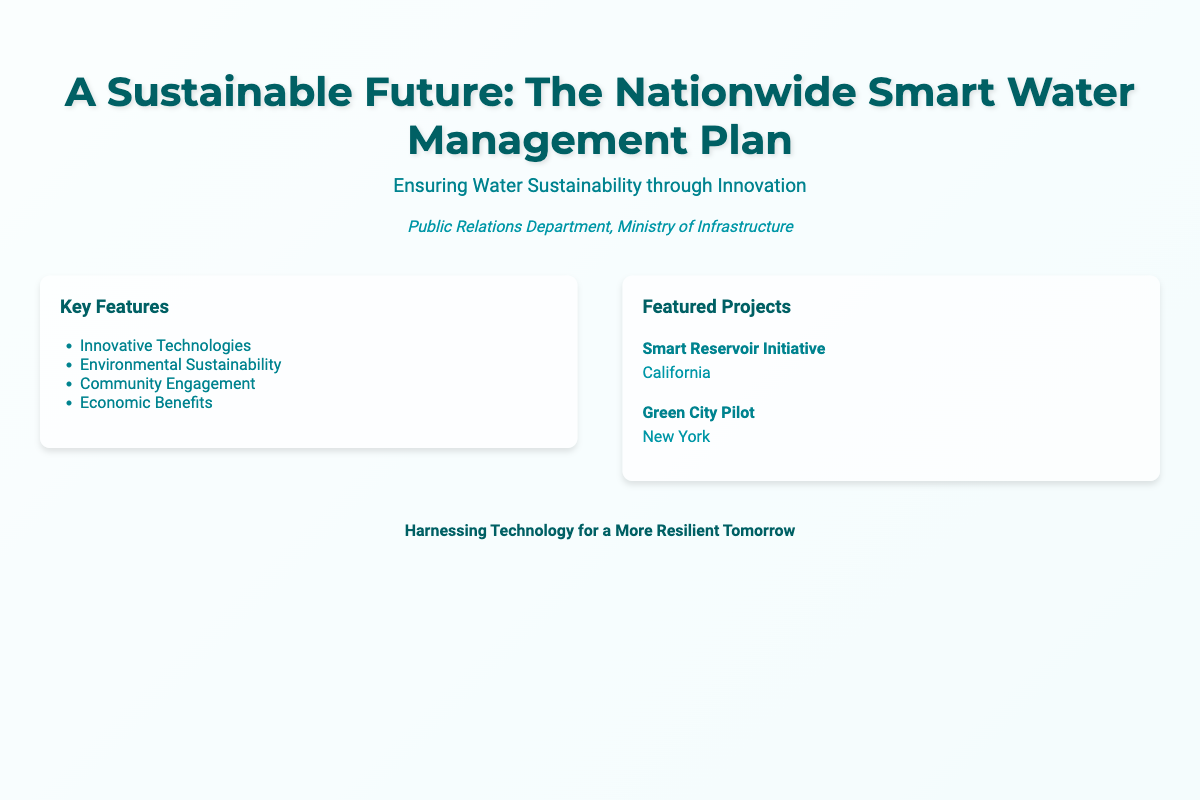What is the title of the document? The title appears prominently at the top of the cover, presenting the main focus of the book.
Answer: A Sustainable Future: The Nationwide Smart Water Management Plan Who is the author? The author is mentioned in the section below the title, representing the responsible department for the document.
Answer: Public Relations Department, Ministry of Infrastructure What is the subtitle? The subtitle provides additional context about the document's purpose, located directly below the title.
Answer: Ensuring Water Sustainability through Innovation What are two key features highlighted? The document lists key features within a bullet-point format for easy readability.
Answer: Innovative Technologies, Environmental Sustainability Which state has a featured project called Smart Reservoir Initiative? The featured projects section provides specific examples of initiatives associated with different locations.
Answer: California What is the main theme of the footer? The footer summarizes the overarching goal of the document succinctly.
Answer: Harnessing Technology for a More Resilient Tomorrow How many featured projects are listed? The document includes a section dedicated to presenting featured projects, allowing for quick understanding.
Answer: 2 What color is the main title text? The color of the title text is an important design element that stands out on the cover.
Answer: #006064 Which city is associated with the Green City Pilot project? This city is mentioned in the context of one of the featured projects, providing a geographical reference.
Answer: New York 